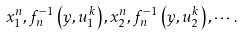Convert formula to latex. <formula><loc_0><loc_0><loc_500><loc_500>x _ { 1 } ^ { n } , f _ { n } ^ { - 1 } \left ( y , u _ { 1 } ^ { k } \right ) , x _ { 2 } ^ { n } , f _ { n } ^ { - 1 } \left ( y , u _ { 2 } ^ { k } \right ) , \cdots .</formula> 